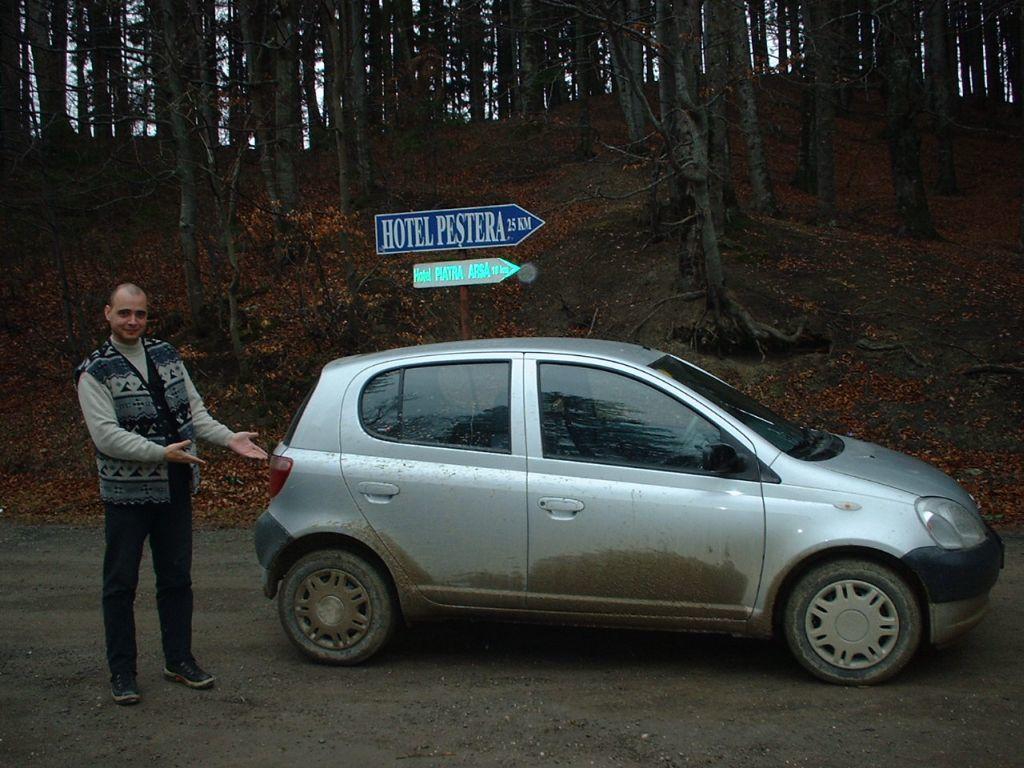In one or two sentences, can you explain what this image depicts? In this image I see a car which is of white in color and I see a man over here who is standing and I see that he is smiling and I see the road. In the background I see 2 boards on which there are boards written and I see number of trees. 